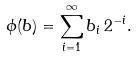<formula> <loc_0><loc_0><loc_500><loc_500>\phi ( b ) = \sum _ { i = 1 } ^ { \infty } b _ { i } \, 2 ^ { - i } .</formula> 